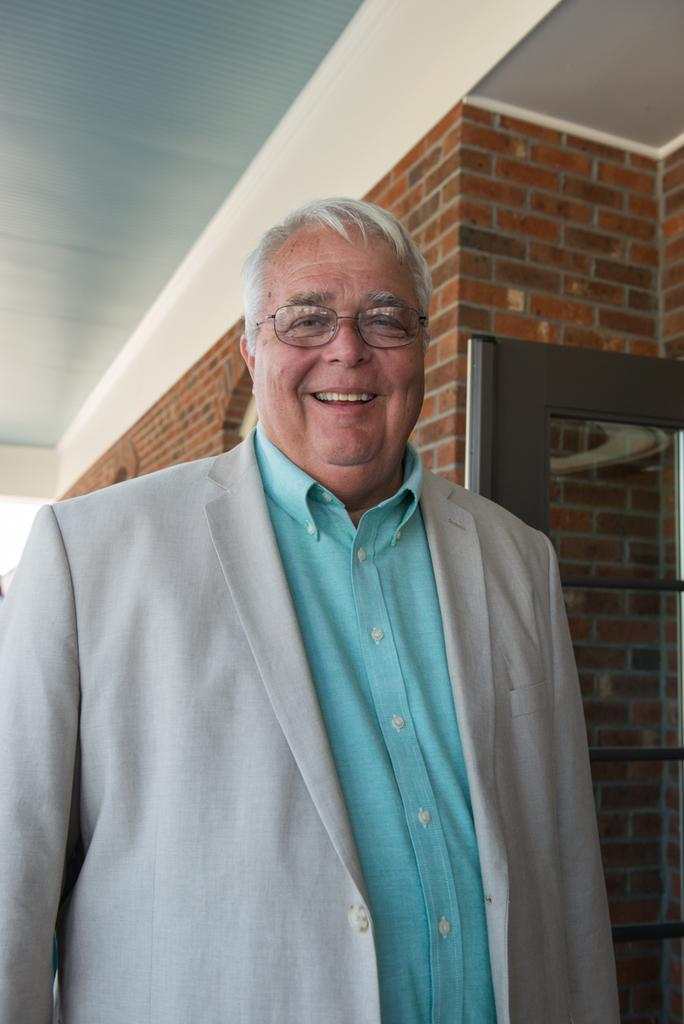What is the main subject of the image? There is a person standing in the image. What is the person doing in the image? The person is smiling. What type of structure is visible in the image? There is a building in the image. What part of the building can be seen in the image? There is a door in the image. Can you tell me how many basketballs are hanging from the person's neck in the image? There are no basketballs present in the image. What type of locket can be seen around the person's neck in the image? There is no locket visible around the person's neck in the image. 